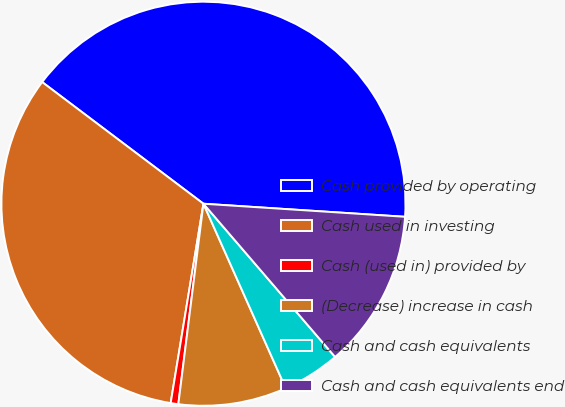Convert chart to OTSL. <chart><loc_0><loc_0><loc_500><loc_500><pie_chart><fcel>Cash provided by operating<fcel>Cash used in investing<fcel>Cash (used in) provided by<fcel>(Decrease) increase in cash<fcel>Cash and cash equivalents<fcel>Cash and cash equivalents end<nl><fcel>40.74%<fcel>32.69%<fcel>0.61%<fcel>8.66%<fcel>4.62%<fcel>12.67%<nl></chart> 